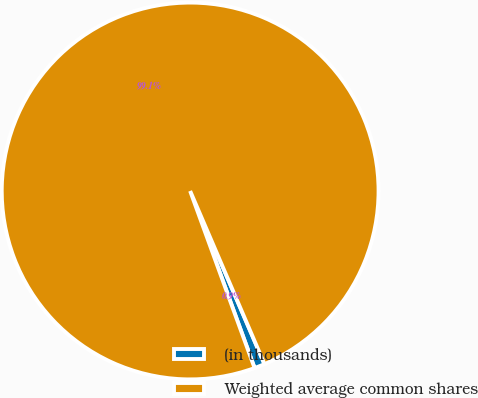Convert chart to OTSL. <chart><loc_0><loc_0><loc_500><loc_500><pie_chart><fcel>(in thousands)<fcel>Weighted average common shares<nl><fcel>0.9%<fcel>99.1%<nl></chart> 